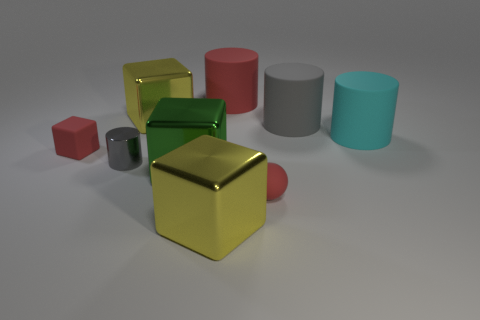Is the color of the rubber cube the same as the rubber sphere?
Provide a succinct answer. Yes. How many other objects are the same material as the cyan object?
Offer a terse response. 4. What number of big gray cylinders are left of the yellow object in front of the red thing to the left of the tiny cylinder?
Give a very brief answer. 0. How many matte things are either small blocks or large things?
Your answer should be compact. 4. How big is the yellow metal cube that is in front of the gray object in front of the small rubber block?
Provide a short and direct response. Large. Do the cylinder in front of the red cube and the thing on the right side of the big gray object have the same color?
Provide a short and direct response. No. The big thing that is both behind the cyan cylinder and to the left of the big red thing is what color?
Offer a very short reply. Yellow. Is the material of the small ball the same as the large gray cylinder?
Your response must be concise. Yes. What number of large things are matte cubes or brown metal things?
Provide a succinct answer. 0. Is there any other thing that is the same shape as the cyan thing?
Make the answer very short. Yes. 